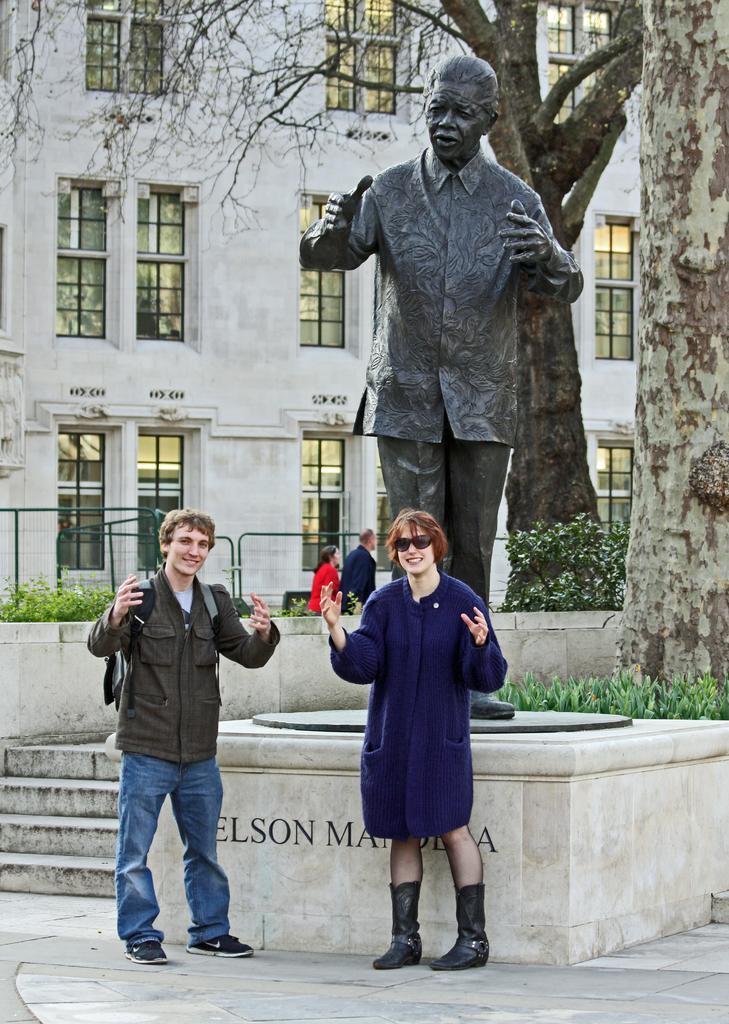How would you summarize this image in a sentence or two? In the foreground of this image, there is a couple standing in front of a statue. In the background, there are plants, railing, stairs, trees and a building. 